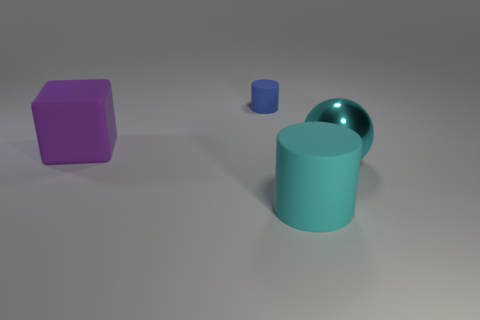Add 3 tiny things. How many objects exist? 7 Subtract all spheres. How many objects are left? 3 Subtract all brown metallic cubes. Subtract all tiny blue matte objects. How many objects are left? 3 Add 4 blocks. How many blocks are left? 5 Add 3 tiny rubber cylinders. How many tiny rubber cylinders exist? 4 Subtract 0 brown spheres. How many objects are left? 4 